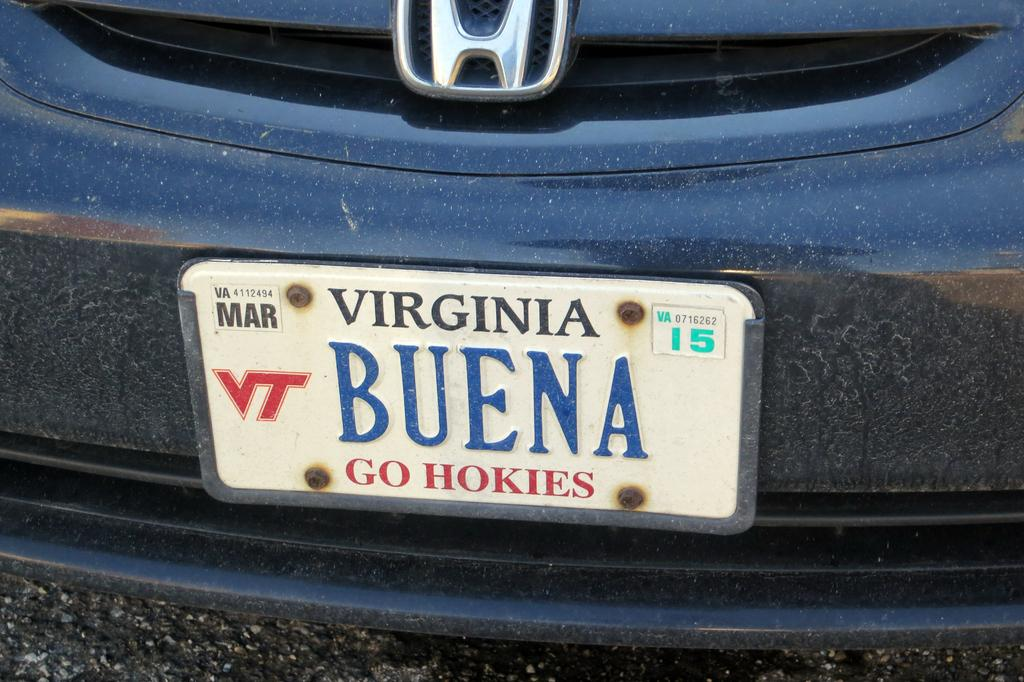<image>
Summarize the visual content of the image. A blue vehicle with the license plate that reads Virginia BUENA. 